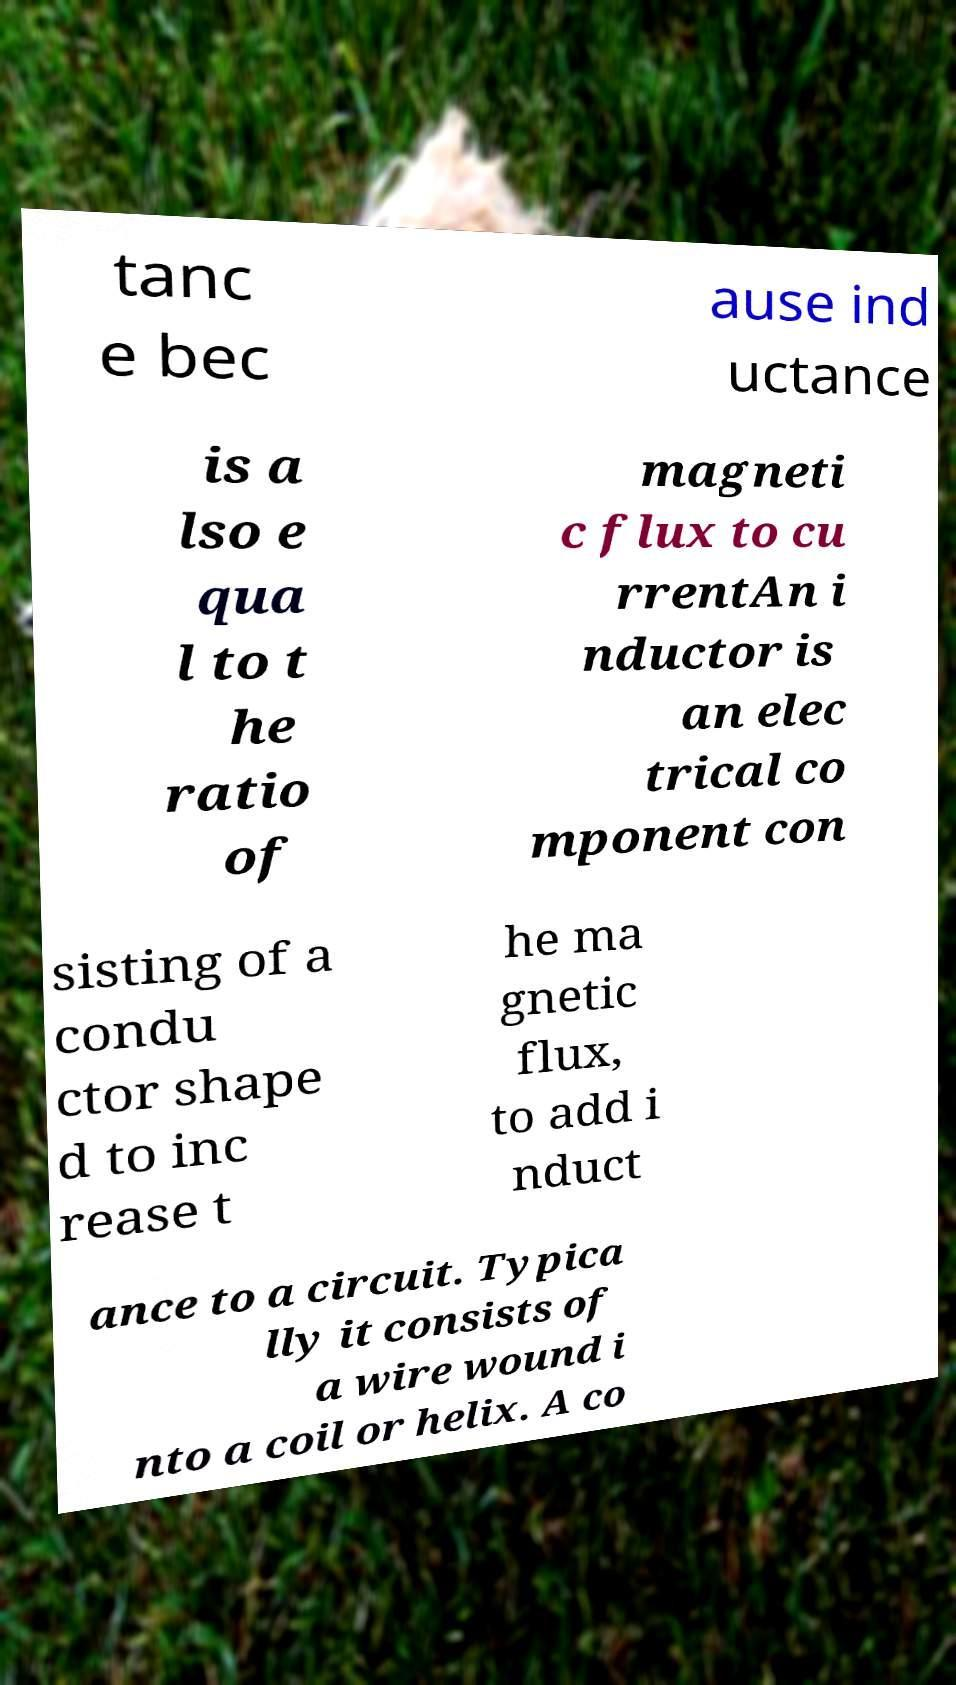Could you assist in decoding the text presented in this image and type it out clearly? tanc e bec ause ind uctance is a lso e qua l to t he ratio of magneti c flux to cu rrentAn i nductor is an elec trical co mponent con sisting of a condu ctor shape d to inc rease t he ma gnetic flux, to add i nduct ance to a circuit. Typica lly it consists of a wire wound i nto a coil or helix. A co 